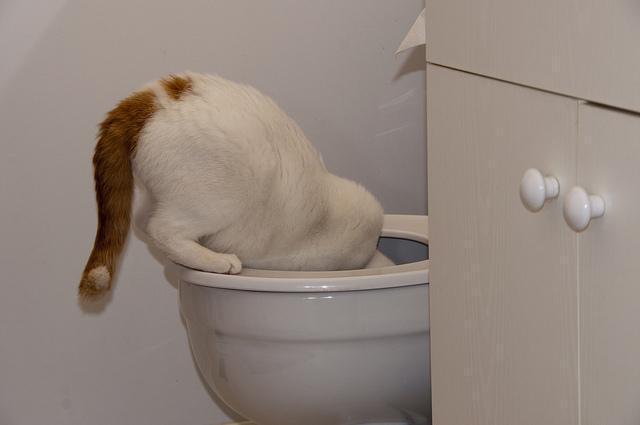How many pets are present?
Give a very brief answer. 1. 